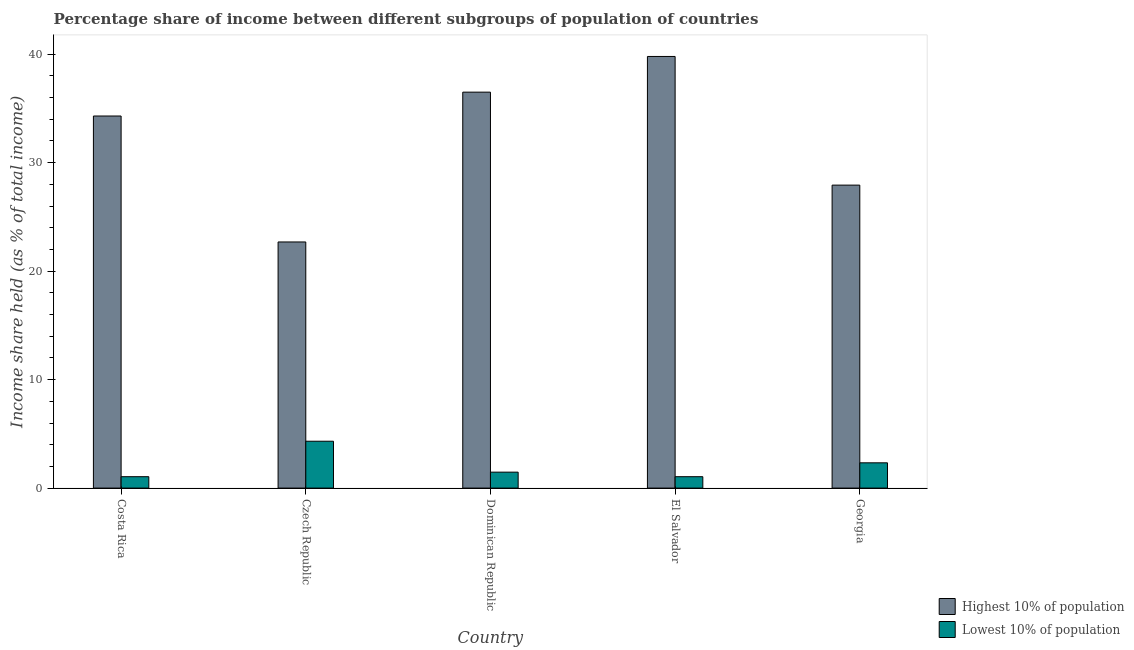Are the number of bars per tick equal to the number of legend labels?
Keep it short and to the point. Yes. How many bars are there on the 1st tick from the right?
Offer a very short reply. 2. What is the label of the 5th group of bars from the left?
Your response must be concise. Georgia. In how many cases, is the number of bars for a given country not equal to the number of legend labels?
Offer a terse response. 0. What is the income share held by highest 10% of the population in El Salvador?
Offer a very short reply. 39.79. Across all countries, what is the maximum income share held by lowest 10% of the population?
Keep it short and to the point. 4.32. Across all countries, what is the minimum income share held by lowest 10% of the population?
Keep it short and to the point. 1.05. In which country was the income share held by highest 10% of the population maximum?
Make the answer very short. El Salvador. What is the total income share held by highest 10% of the population in the graph?
Make the answer very short. 161.21. What is the difference between the income share held by highest 10% of the population in Czech Republic and that in Georgia?
Provide a short and direct response. -5.24. What is the difference between the income share held by lowest 10% of the population in El Salvador and the income share held by highest 10% of the population in Czech Republic?
Provide a short and direct response. -21.64. What is the average income share held by lowest 10% of the population per country?
Your answer should be very brief. 2.04. What is the difference between the income share held by lowest 10% of the population and income share held by highest 10% of the population in El Salvador?
Give a very brief answer. -38.74. What is the ratio of the income share held by highest 10% of the population in Costa Rica to that in Dominican Republic?
Offer a very short reply. 0.94. Is the income share held by lowest 10% of the population in Costa Rica less than that in Georgia?
Offer a terse response. Yes. Is the difference between the income share held by lowest 10% of the population in Costa Rica and El Salvador greater than the difference between the income share held by highest 10% of the population in Costa Rica and El Salvador?
Offer a terse response. Yes. What is the difference between the highest and the second highest income share held by highest 10% of the population?
Offer a very short reply. 3.29. What is the difference between the highest and the lowest income share held by highest 10% of the population?
Keep it short and to the point. 17.1. What does the 1st bar from the left in Costa Rica represents?
Keep it short and to the point. Highest 10% of population. What does the 1st bar from the right in Dominican Republic represents?
Your answer should be very brief. Lowest 10% of population. How many bars are there?
Ensure brevity in your answer.  10. Are all the bars in the graph horizontal?
Keep it short and to the point. No. Does the graph contain any zero values?
Make the answer very short. No. Does the graph contain grids?
Offer a very short reply. No. Where does the legend appear in the graph?
Your answer should be compact. Bottom right. How are the legend labels stacked?
Make the answer very short. Vertical. What is the title of the graph?
Make the answer very short. Percentage share of income between different subgroups of population of countries. Does "UN agencies" appear as one of the legend labels in the graph?
Your response must be concise. No. What is the label or title of the Y-axis?
Provide a succinct answer. Income share held (as % of total income). What is the Income share held (as % of total income) in Highest 10% of population in Costa Rica?
Provide a succinct answer. 34.3. What is the Income share held (as % of total income) of Lowest 10% of population in Costa Rica?
Your answer should be very brief. 1.05. What is the Income share held (as % of total income) in Highest 10% of population in Czech Republic?
Give a very brief answer. 22.69. What is the Income share held (as % of total income) of Lowest 10% of population in Czech Republic?
Give a very brief answer. 4.32. What is the Income share held (as % of total income) in Highest 10% of population in Dominican Republic?
Provide a succinct answer. 36.5. What is the Income share held (as % of total income) of Lowest 10% of population in Dominican Republic?
Keep it short and to the point. 1.47. What is the Income share held (as % of total income) in Highest 10% of population in El Salvador?
Give a very brief answer. 39.79. What is the Income share held (as % of total income) of Lowest 10% of population in El Salvador?
Offer a terse response. 1.05. What is the Income share held (as % of total income) of Highest 10% of population in Georgia?
Provide a succinct answer. 27.93. What is the Income share held (as % of total income) in Lowest 10% of population in Georgia?
Make the answer very short. 2.33. Across all countries, what is the maximum Income share held (as % of total income) of Highest 10% of population?
Your answer should be very brief. 39.79. Across all countries, what is the maximum Income share held (as % of total income) of Lowest 10% of population?
Ensure brevity in your answer.  4.32. Across all countries, what is the minimum Income share held (as % of total income) in Highest 10% of population?
Your answer should be compact. 22.69. Across all countries, what is the minimum Income share held (as % of total income) of Lowest 10% of population?
Provide a succinct answer. 1.05. What is the total Income share held (as % of total income) of Highest 10% of population in the graph?
Offer a terse response. 161.21. What is the total Income share held (as % of total income) in Lowest 10% of population in the graph?
Make the answer very short. 10.22. What is the difference between the Income share held (as % of total income) of Highest 10% of population in Costa Rica and that in Czech Republic?
Your answer should be compact. 11.61. What is the difference between the Income share held (as % of total income) in Lowest 10% of population in Costa Rica and that in Czech Republic?
Your answer should be very brief. -3.27. What is the difference between the Income share held (as % of total income) of Lowest 10% of population in Costa Rica and that in Dominican Republic?
Provide a short and direct response. -0.42. What is the difference between the Income share held (as % of total income) in Highest 10% of population in Costa Rica and that in El Salvador?
Give a very brief answer. -5.49. What is the difference between the Income share held (as % of total income) of Highest 10% of population in Costa Rica and that in Georgia?
Offer a terse response. 6.37. What is the difference between the Income share held (as % of total income) in Lowest 10% of population in Costa Rica and that in Georgia?
Make the answer very short. -1.28. What is the difference between the Income share held (as % of total income) in Highest 10% of population in Czech Republic and that in Dominican Republic?
Provide a short and direct response. -13.81. What is the difference between the Income share held (as % of total income) of Lowest 10% of population in Czech Republic and that in Dominican Republic?
Provide a succinct answer. 2.85. What is the difference between the Income share held (as % of total income) of Highest 10% of population in Czech Republic and that in El Salvador?
Offer a terse response. -17.1. What is the difference between the Income share held (as % of total income) of Lowest 10% of population in Czech Republic and that in El Salvador?
Ensure brevity in your answer.  3.27. What is the difference between the Income share held (as % of total income) of Highest 10% of population in Czech Republic and that in Georgia?
Offer a very short reply. -5.24. What is the difference between the Income share held (as % of total income) of Lowest 10% of population in Czech Republic and that in Georgia?
Give a very brief answer. 1.99. What is the difference between the Income share held (as % of total income) in Highest 10% of population in Dominican Republic and that in El Salvador?
Give a very brief answer. -3.29. What is the difference between the Income share held (as % of total income) of Lowest 10% of population in Dominican Republic and that in El Salvador?
Give a very brief answer. 0.42. What is the difference between the Income share held (as % of total income) in Highest 10% of population in Dominican Republic and that in Georgia?
Provide a short and direct response. 8.57. What is the difference between the Income share held (as % of total income) in Lowest 10% of population in Dominican Republic and that in Georgia?
Ensure brevity in your answer.  -0.86. What is the difference between the Income share held (as % of total income) of Highest 10% of population in El Salvador and that in Georgia?
Provide a succinct answer. 11.86. What is the difference between the Income share held (as % of total income) of Lowest 10% of population in El Salvador and that in Georgia?
Make the answer very short. -1.28. What is the difference between the Income share held (as % of total income) in Highest 10% of population in Costa Rica and the Income share held (as % of total income) in Lowest 10% of population in Czech Republic?
Make the answer very short. 29.98. What is the difference between the Income share held (as % of total income) of Highest 10% of population in Costa Rica and the Income share held (as % of total income) of Lowest 10% of population in Dominican Republic?
Make the answer very short. 32.83. What is the difference between the Income share held (as % of total income) in Highest 10% of population in Costa Rica and the Income share held (as % of total income) in Lowest 10% of population in El Salvador?
Provide a succinct answer. 33.25. What is the difference between the Income share held (as % of total income) in Highest 10% of population in Costa Rica and the Income share held (as % of total income) in Lowest 10% of population in Georgia?
Give a very brief answer. 31.97. What is the difference between the Income share held (as % of total income) in Highest 10% of population in Czech Republic and the Income share held (as % of total income) in Lowest 10% of population in Dominican Republic?
Provide a succinct answer. 21.22. What is the difference between the Income share held (as % of total income) in Highest 10% of population in Czech Republic and the Income share held (as % of total income) in Lowest 10% of population in El Salvador?
Keep it short and to the point. 21.64. What is the difference between the Income share held (as % of total income) in Highest 10% of population in Czech Republic and the Income share held (as % of total income) in Lowest 10% of population in Georgia?
Give a very brief answer. 20.36. What is the difference between the Income share held (as % of total income) of Highest 10% of population in Dominican Republic and the Income share held (as % of total income) of Lowest 10% of population in El Salvador?
Keep it short and to the point. 35.45. What is the difference between the Income share held (as % of total income) of Highest 10% of population in Dominican Republic and the Income share held (as % of total income) of Lowest 10% of population in Georgia?
Make the answer very short. 34.17. What is the difference between the Income share held (as % of total income) of Highest 10% of population in El Salvador and the Income share held (as % of total income) of Lowest 10% of population in Georgia?
Your answer should be very brief. 37.46. What is the average Income share held (as % of total income) of Highest 10% of population per country?
Provide a short and direct response. 32.24. What is the average Income share held (as % of total income) in Lowest 10% of population per country?
Give a very brief answer. 2.04. What is the difference between the Income share held (as % of total income) of Highest 10% of population and Income share held (as % of total income) of Lowest 10% of population in Costa Rica?
Your response must be concise. 33.25. What is the difference between the Income share held (as % of total income) in Highest 10% of population and Income share held (as % of total income) in Lowest 10% of population in Czech Republic?
Your response must be concise. 18.37. What is the difference between the Income share held (as % of total income) in Highest 10% of population and Income share held (as % of total income) in Lowest 10% of population in Dominican Republic?
Provide a succinct answer. 35.03. What is the difference between the Income share held (as % of total income) of Highest 10% of population and Income share held (as % of total income) of Lowest 10% of population in El Salvador?
Give a very brief answer. 38.74. What is the difference between the Income share held (as % of total income) in Highest 10% of population and Income share held (as % of total income) in Lowest 10% of population in Georgia?
Make the answer very short. 25.6. What is the ratio of the Income share held (as % of total income) of Highest 10% of population in Costa Rica to that in Czech Republic?
Keep it short and to the point. 1.51. What is the ratio of the Income share held (as % of total income) in Lowest 10% of population in Costa Rica to that in Czech Republic?
Offer a terse response. 0.24. What is the ratio of the Income share held (as % of total income) of Highest 10% of population in Costa Rica to that in Dominican Republic?
Your answer should be compact. 0.94. What is the ratio of the Income share held (as % of total income) of Lowest 10% of population in Costa Rica to that in Dominican Republic?
Ensure brevity in your answer.  0.71. What is the ratio of the Income share held (as % of total income) in Highest 10% of population in Costa Rica to that in El Salvador?
Keep it short and to the point. 0.86. What is the ratio of the Income share held (as % of total income) of Highest 10% of population in Costa Rica to that in Georgia?
Give a very brief answer. 1.23. What is the ratio of the Income share held (as % of total income) in Lowest 10% of population in Costa Rica to that in Georgia?
Your answer should be very brief. 0.45. What is the ratio of the Income share held (as % of total income) in Highest 10% of population in Czech Republic to that in Dominican Republic?
Your answer should be compact. 0.62. What is the ratio of the Income share held (as % of total income) in Lowest 10% of population in Czech Republic to that in Dominican Republic?
Offer a terse response. 2.94. What is the ratio of the Income share held (as % of total income) in Highest 10% of population in Czech Republic to that in El Salvador?
Offer a very short reply. 0.57. What is the ratio of the Income share held (as % of total income) of Lowest 10% of population in Czech Republic to that in El Salvador?
Your answer should be very brief. 4.11. What is the ratio of the Income share held (as % of total income) of Highest 10% of population in Czech Republic to that in Georgia?
Your response must be concise. 0.81. What is the ratio of the Income share held (as % of total income) in Lowest 10% of population in Czech Republic to that in Georgia?
Your response must be concise. 1.85. What is the ratio of the Income share held (as % of total income) in Highest 10% of population in Dominican Republic to that in El Salvador?
Keep it short and to the point. 0.92. What is the ratio of the Income share held (as % of total income) of Lowest 10% of population in Dominican Republic to that in El Salvador?
Give a very brief answer. 1.4. What is the ratio of the Income share held (as % of total income) of Highest 10% of population in Dominican Republic to that in Georgia?
Keep it short and to the point. 1.31. What is the ratio of the Income share held (as % of total income) of Lowest 10% of population in Dominican Republic to that in Georgia?
Ensure brevity in your answer.  0.63. What is the ratio of the Income share held (as % of total income) in Highest 10% of population in El Salvador to that in Georgia?
Provide a succinct answer. 1.42. What is the ratio of the Income share held (as % of total income) of Lowest 10% of population in El Salvador to that in Georgia?
Your answer should be compact. 0.45. What is the difference between the highest and the second highest Income share held (as % of total income) of Highest 10% of population?
Make the answer very short. 3.29. What is the difference between the highest and the second highest Income share held (as % of total income) in Lowest 10% of population?
Your response must be concise. 1.99. What is the difference between the highest and the lowest Income share held (as % of total income) in Highest 10% of population?
Your answer should be very brief. 17.1. What is the difference between the highest and the lowest Income share held (as % of total income) in Lowest 10% of population?
Ensure brevity in your answer.  3.27. 